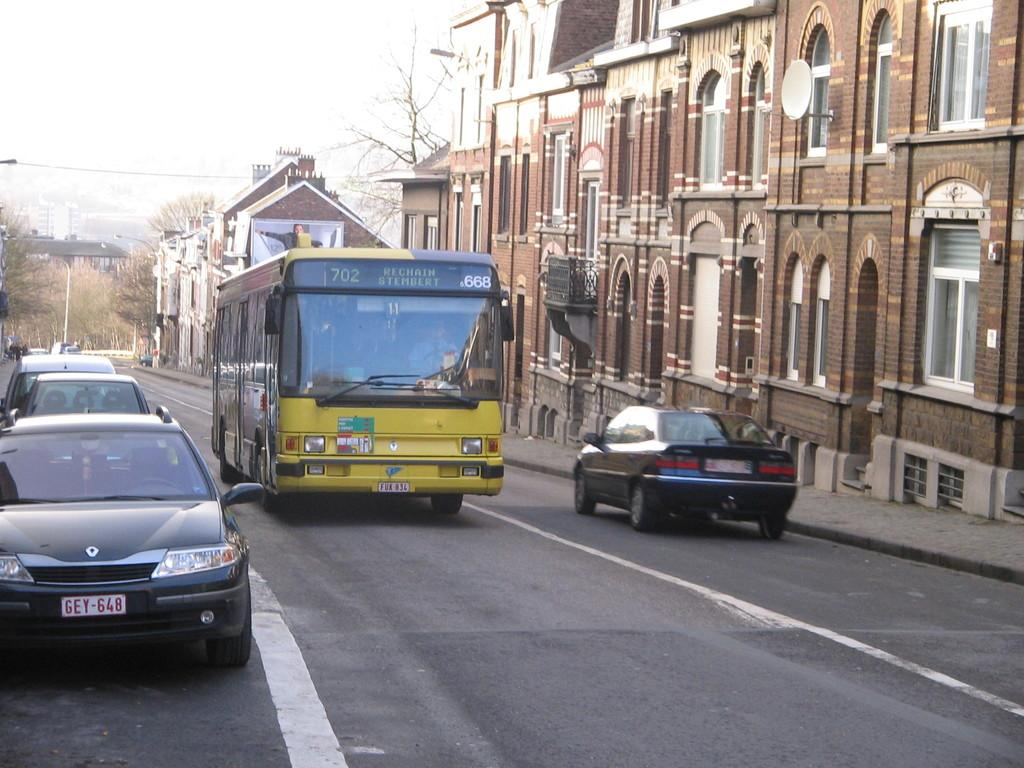<image>
Present a compact description of the photo's key features. A city bus numbered 668 bound for Rechain Stembert. 